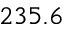Convert formula to latex. <formula><loc_0><loc_0><loc_500><loc_500>2 3 5 . 6</formula> 